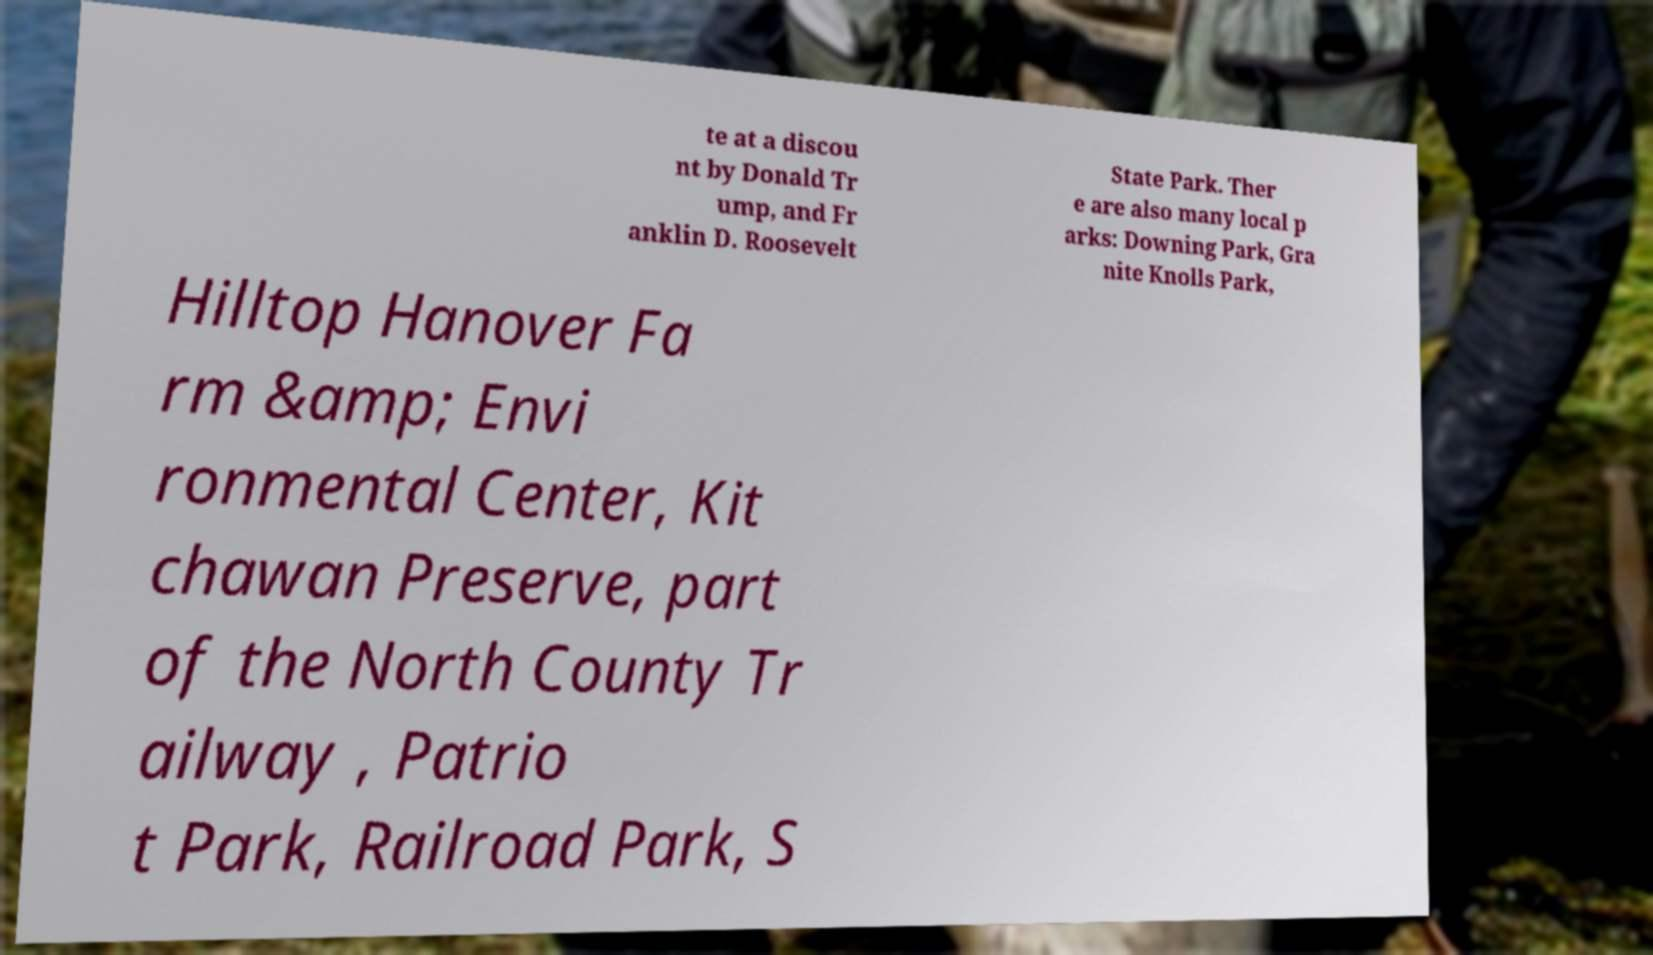Can you read and provide the text displayed in the image?This photo seems to have some interesting text. Can you extract and type it out for me? te at a discou nt by Donald Tr ump, and Fr anklin D. Roosevelt State Park. Ther e are also many local p arks: Downing Park, Gra nite Knolls Park, Hilltop Hanover Fa rm &amp; Envi ronmental Center, Kit chawan Preserve, part of the North County Tr ailway , Patrio t Park, Railroad Park, S 